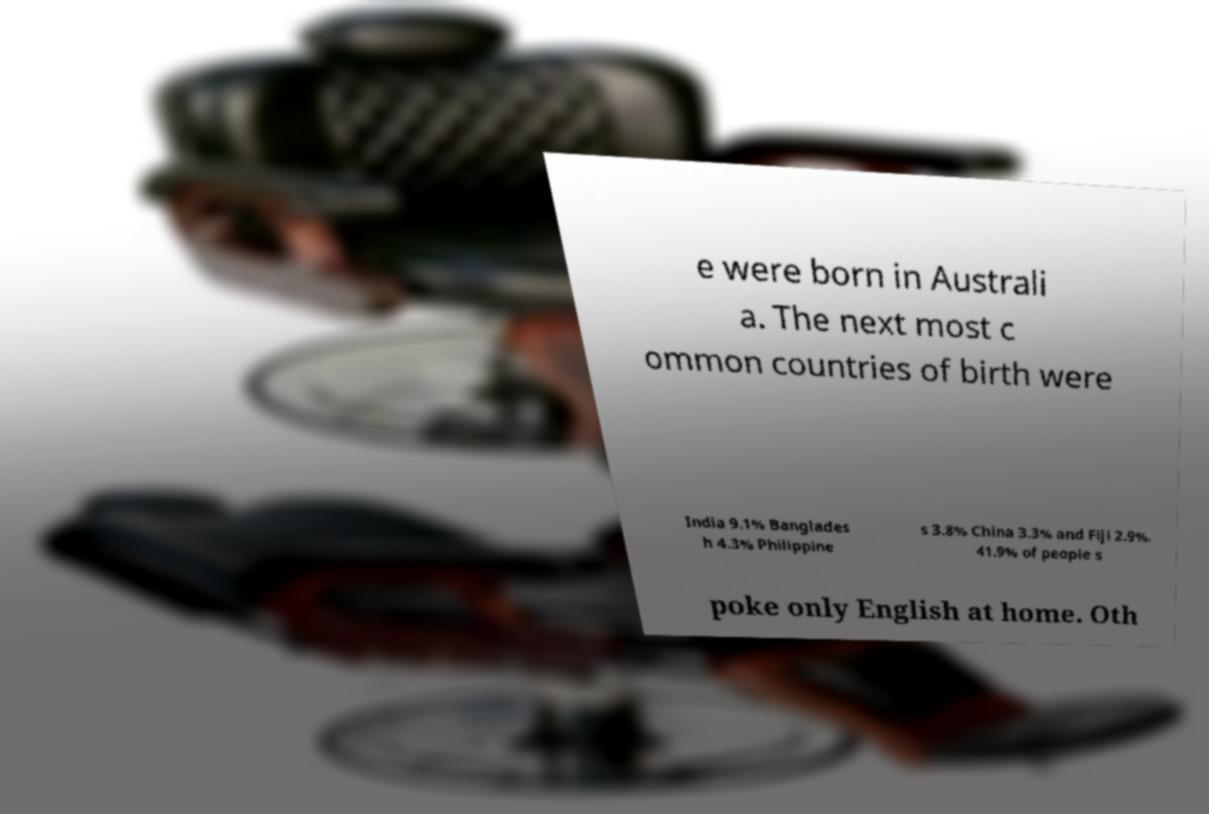Please read and relay the text visible in this image. What does it say? e were born in Australi a. The next most c ommon countries of birth were India 9.1% Banglades h 4.3% Philippine s 3.8% China 3.3% and Fiji 2.9%. 41.9% of people s poke only English at home. Oth 